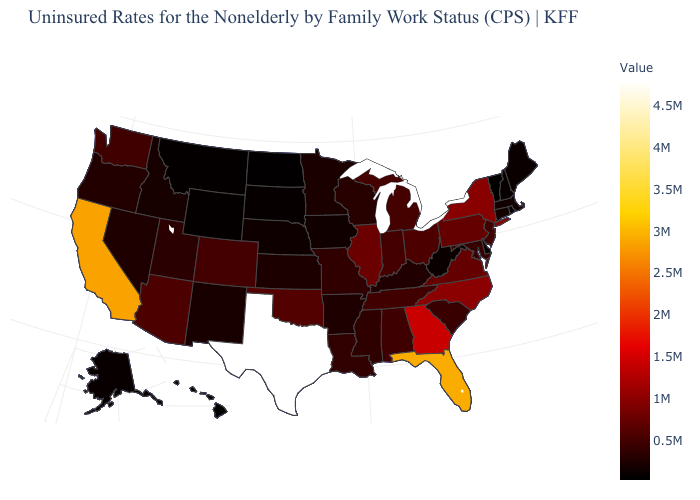Which states hav the highest value in the MidWest?
Be succinct. Illinois. Is the legend a continuous bar?
Give a very brief answer. Yes. Does Illinois have the highest value in the MidWest?
Be succinct. Yes. Does Colorado have the lowest value in the USA?
Answer briefly. No. Does Oklahoma have a lower value than Alaska?
Concise answer only. No. Among the states that border Wisconsin , which have the highest value?
Concise answer only. Illinois. Which states have the highest value in the USA?
Keep it brief. Texas. 